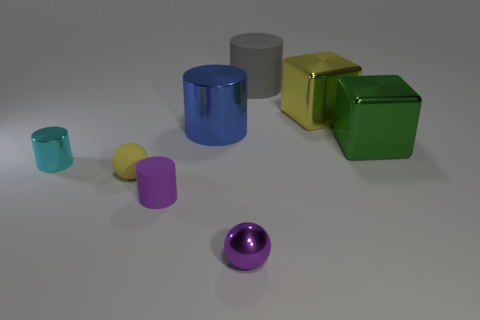Subtract all green cylinders. Subtract all gray balls. How many cylinders are left? 4 Add 2 small cylinders. How many objects exist? 10 Subtract all blocks. How many objects are left? 6 Subtract all gray objects. Subtract all big blue metallic things. How many objects are left? 6 Add 5 tiny yellow spheres. How many tiny yellow spheres are left? 6 Add 2 metal spheres. How many metal spheres exist? 3 Subtract 0 cyan balls. How many objects are left? 8 